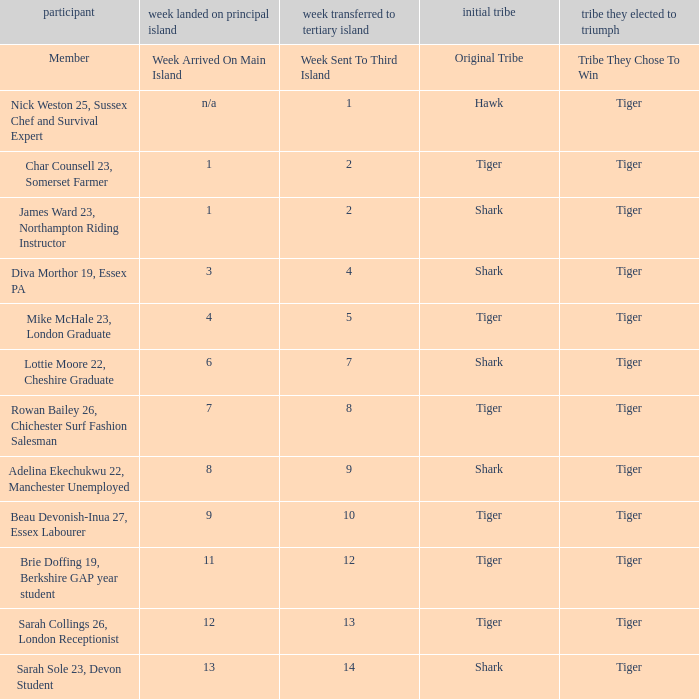In which week did the participant, originally from the shark tribe and sent to the third island on week 14, arrive on the main island? 13.0. 